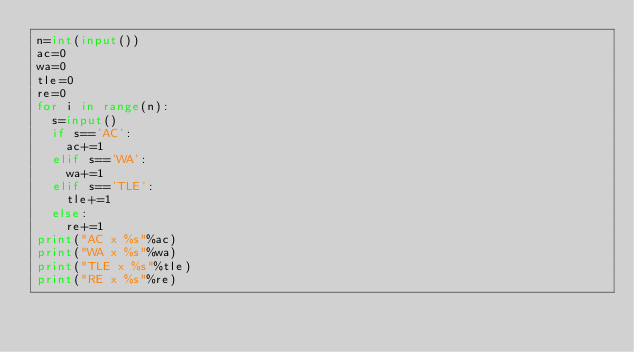Convert code to text. <code><loc_0><loc_0><loc_500><loc_500><_Python_>n=int(input())
ac=0
wa=0
tle=0
re=0
for i in range(n):
  s=input()
  if s=='AC':
    ac+=1
  elif s=='WA':
    wa+=1
  elif s=='TLE':
    tle+=1
  else:
    re+=1
print("AC x %s"%ac)
print("WA x %s"%wa)
print("TLE x %s"%tle)
print("RE x %s"%re)</code> 